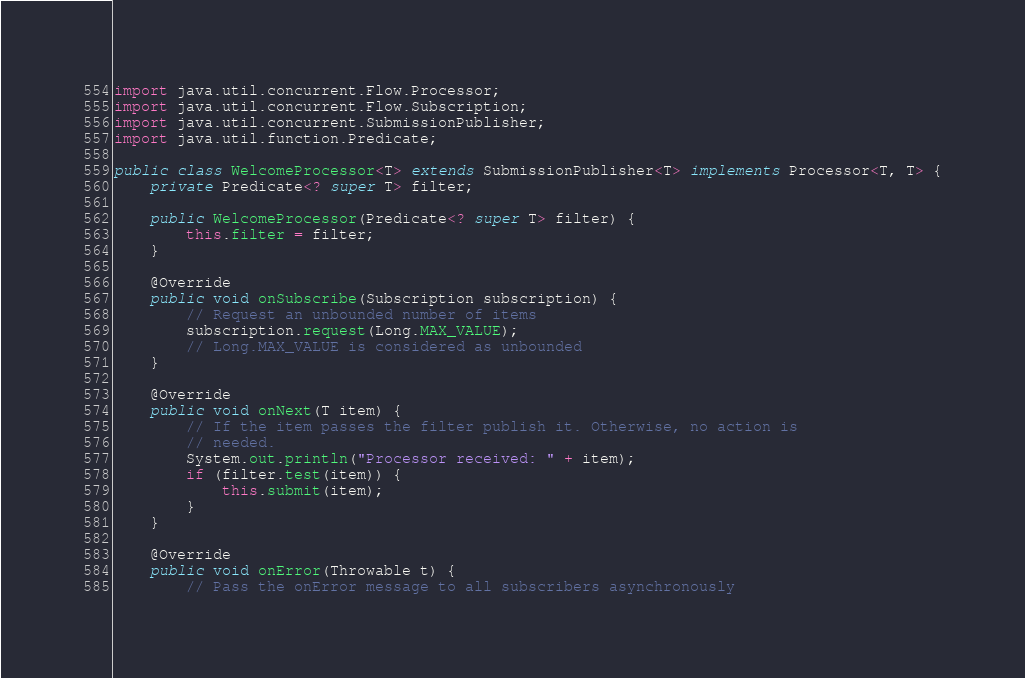<code> <loc_0><loc_0><loc_500><loc_500><_Java_>

import java.util.concurrent.Flow.Processor;
import java.util.concurrent.Flow.Subscription;
import java.util.concurrent.SubmissionPublisher;
import java.util.function.Predicate;

public class WelcomeProcessor<T> extends SubmissionPublisher<T> implements Processor<T, T> {
	private Predicate<? super T> filter;

	public WelcomeProcessor(Predicate<? super T> filter) {
		this.filter = filter;
	}

	@Override
	public void onSubscribe(Subscription subscription) {
		// Request an unbounded number of items
		subscription.request(Long.MAX_VALUE);
		// Long.MAX_VALUE is considered as unbounded 
	}

	@Override
	public void onNext(T item) {
		// If the item passes the filter publish it. Otherwise, no action is
		// needed.
		System.out.println("Processor received: " + item);
		if (filter.test(item)) {
			this.submit(item);
		}
	}

	@Override
	public void onError(Throwable t) {
		// Pass the onError message to all subscribers asynchronously</code> 